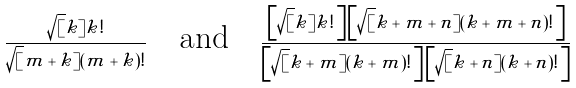<formula> <loc_0><loc_0><loc_500><loc_500>\frac { \sqrt { [ } k ] { k ! } } { \sqrt { [ } m + k ] { ( m + k ) ! } } \quad \text {and} \quad \frac { \left [ \sqrt { [ } k ] { k ! } \, \right ] \left [ \sqrt { [ } k + m + n ] { ( k + m + n ) ! } \, \right ] } { \left [ \sqrt { [ } k + m ] { ( k + m ) ! } \, \right ] \left [ \sqrt { [ } k + n ] { ( k + n ) ! } \, \right ] }</formula> 